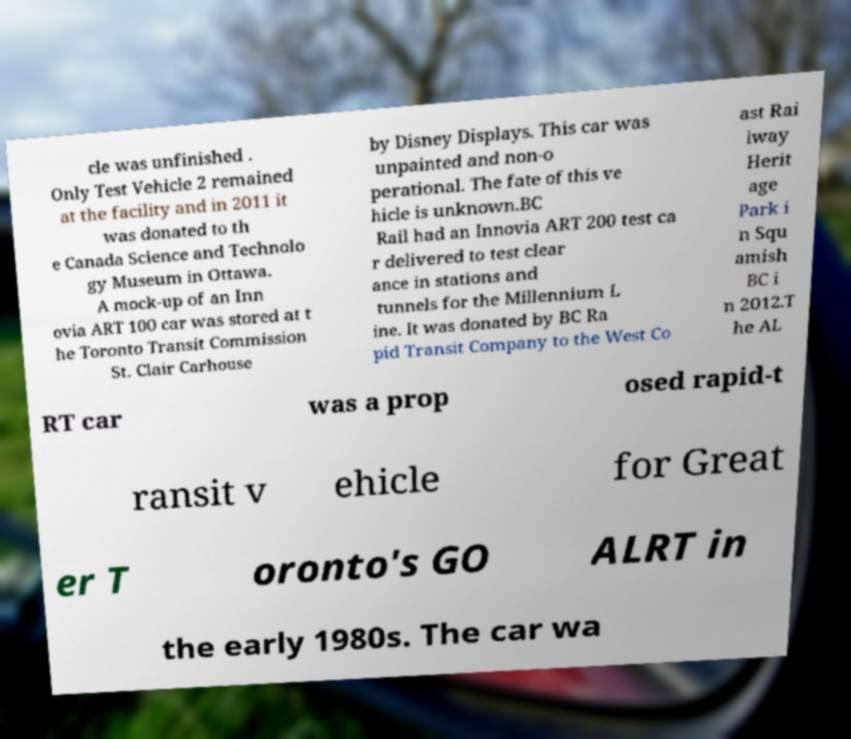There's text embedded in this image that I need extracted. Can you transcribe it verbatim? cle was unfinished . Only Test Vehicle 2 remained at the facility and in 2011 it was donated to th e Canada Science and Technolo gy Museum in Ottawa. A mock-up of an Inn ovia ART 100 car was stored at t he Toronto Transit Commission St. Clair Carhouse by Disney Displays. This car was unpainted and non-o perational. The fate of this ve hicle is unknown.BC Rail had an Innovia ART 200 test ca r delivered to test clear ance in stations and tunnels for the Millennium L ine. It was donated by BC Ra pid Transit Company to the West Co ast Rai lway Herit age Park i n Squ amish BC i n 2012.T he AL RT car was a prop osed rapid-t ransit v ehicle for Great er T oronto's GO ALRT in the early 1980s. The car wa 